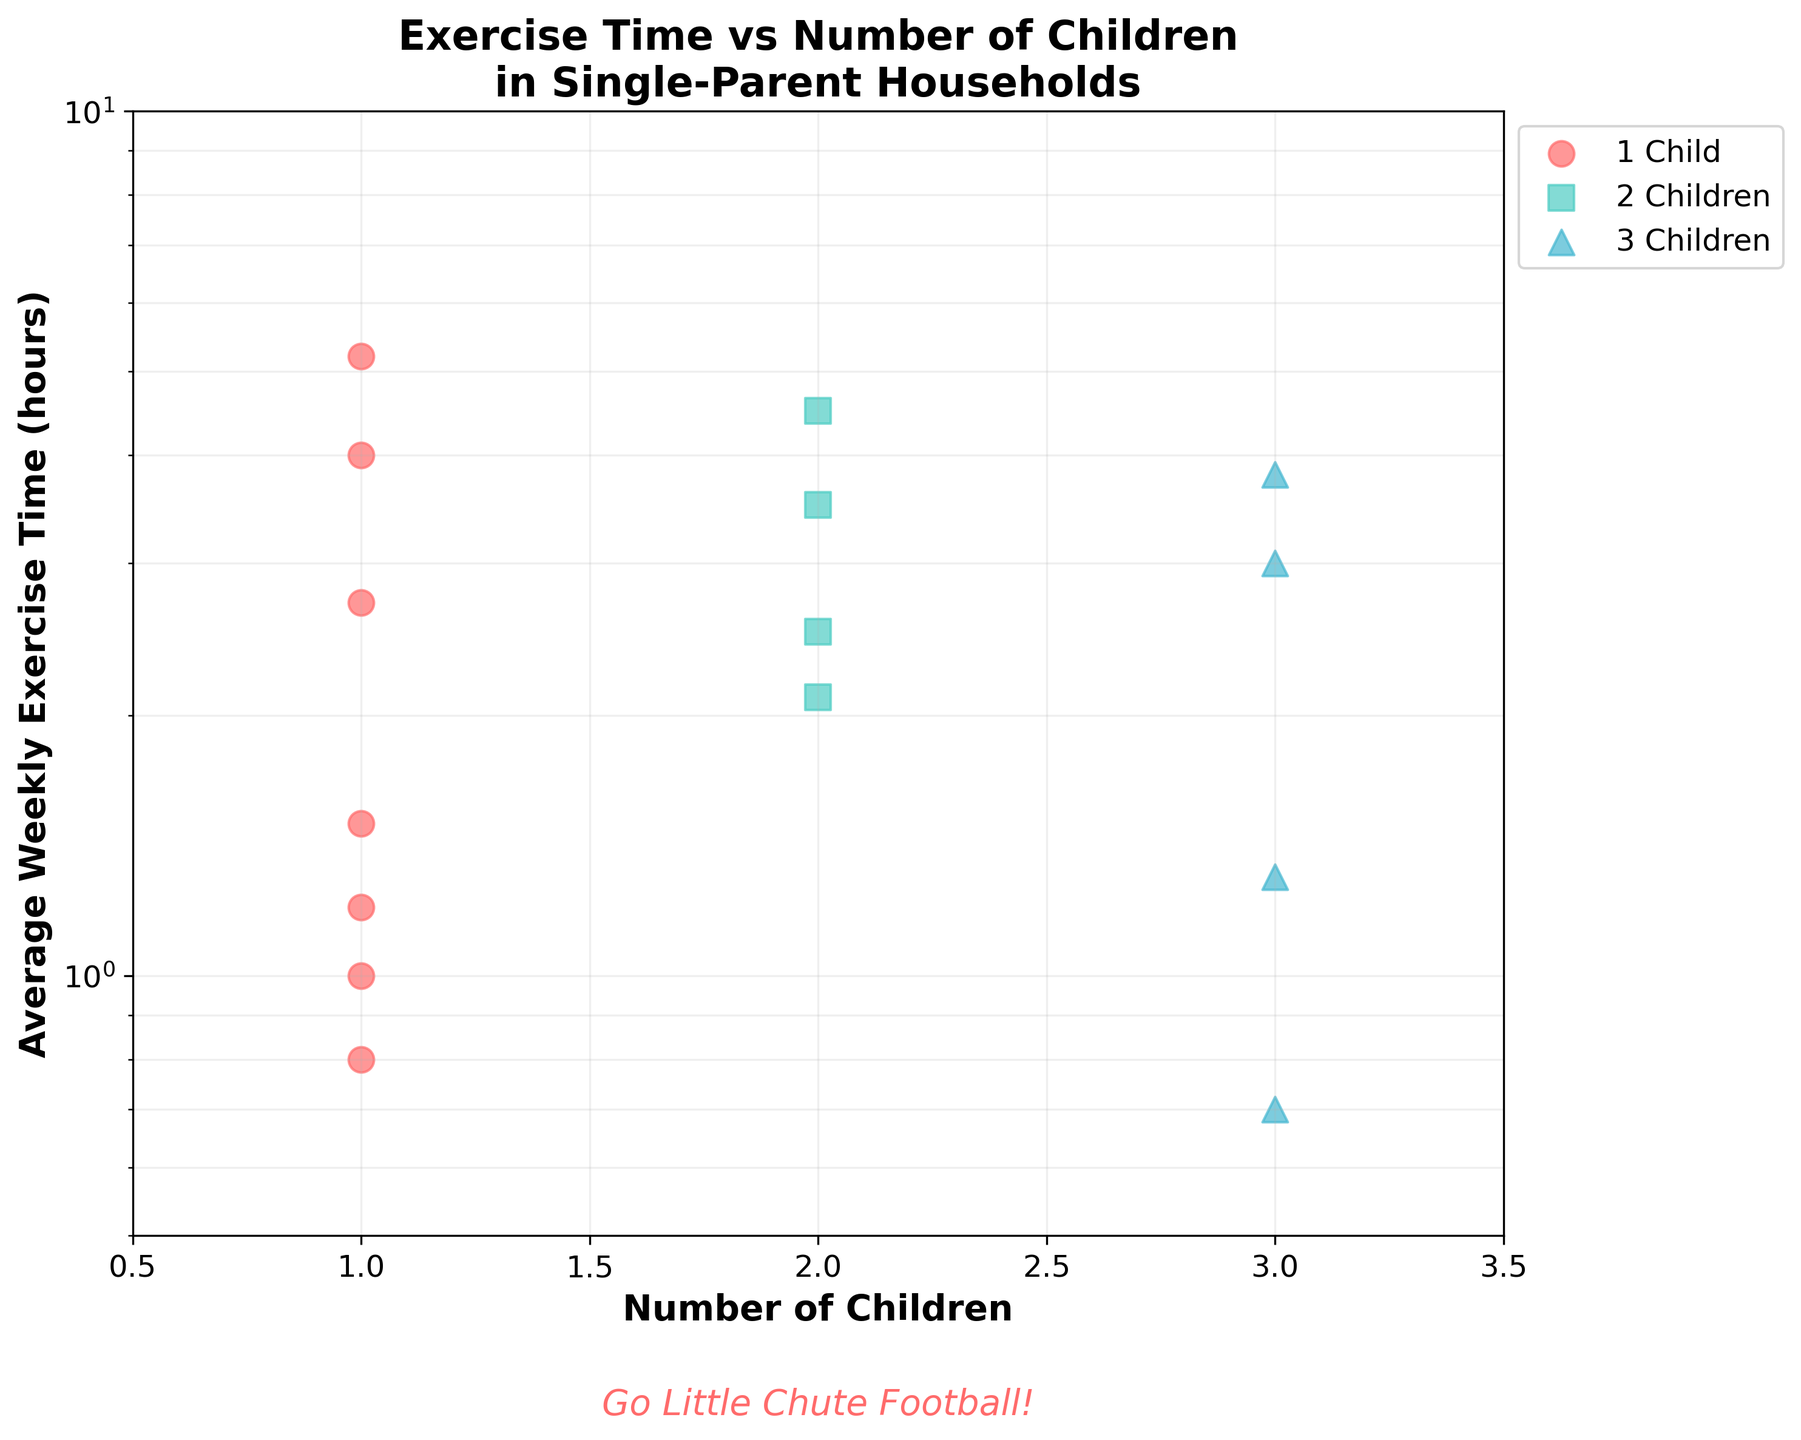What is the title of the scatter plot? The title of the scatter plot is written at the top center of the figure. It reads, "Exercise Time vs Number of Children\nin Single-Parent Households."
Answer: "Exercise Time vs Number of Children\nin Single-Parent Households" How many data points are there for households with exactly 1 child? To find the number of data points for 1-child households, we need to count the red circles. There are 7 red circles in the plot.
Answer: 7 What is the range of Average Weekly Exercise Time for households with 2 children? We need to look for the green square markers and observe the y-axis log-scale values. The green squares are scattered between 2.5 and 4.5 hours.
Answer: From 2.5 to 4.5 hours Which group has the highest individual Average Weekly Exercise Time, and what is that value? We identify the marker that is highest on the log-scale y-axis. The highest marker is a red circle (1 child) at 5.2 hours.
Answer: 1 child, 5.2 hours How does the Average Weekly Exercise Time compare between households with 1 child and 3 children? We observe that most red circles (1 child) are found between 0.8 to 5.2 hours, whereas purple triangles (3 children) are between 0.7 to 3.8 hours. This indicates that 1-child households have a wider range of exercise hours and include the highest value.
Answer: 1-child has a wider range and higher max value What is the approximate median Average Weekly Exercise Time for households with 2 children? The green squares are plotted at 2.1, 2.5, 3.0, and 3.5 hours. As there are four values, the median will be the average of the middle two: (2.5 + 3.0) / 2 = 2.75 hours.
Answer: 2.75 hours What is the general trend in Exercise Time as the Number of Children increases? We compare the median values of each group. Households with 1 child have a wide and high range, 2 children have moderate values, and 3 children show smaller exercise times generally, indicating a decreasing trend.
Answer: Decreasing trend What colors represent the households with different numbers of children? The scatter plot uses three distinct colors. Red circles represent 1 child, green squares represent 2 children, and purple triangles represent 3 children.
Answer: Red (1 child), Green (2 children), Purple (3 children) Where is the encouraging phrase for the Little Chute football team located? The encouraging phrase is located below the x-axis. It reads "Go Little Chute Football!" in italic red text.
Answer: Below x-axis 